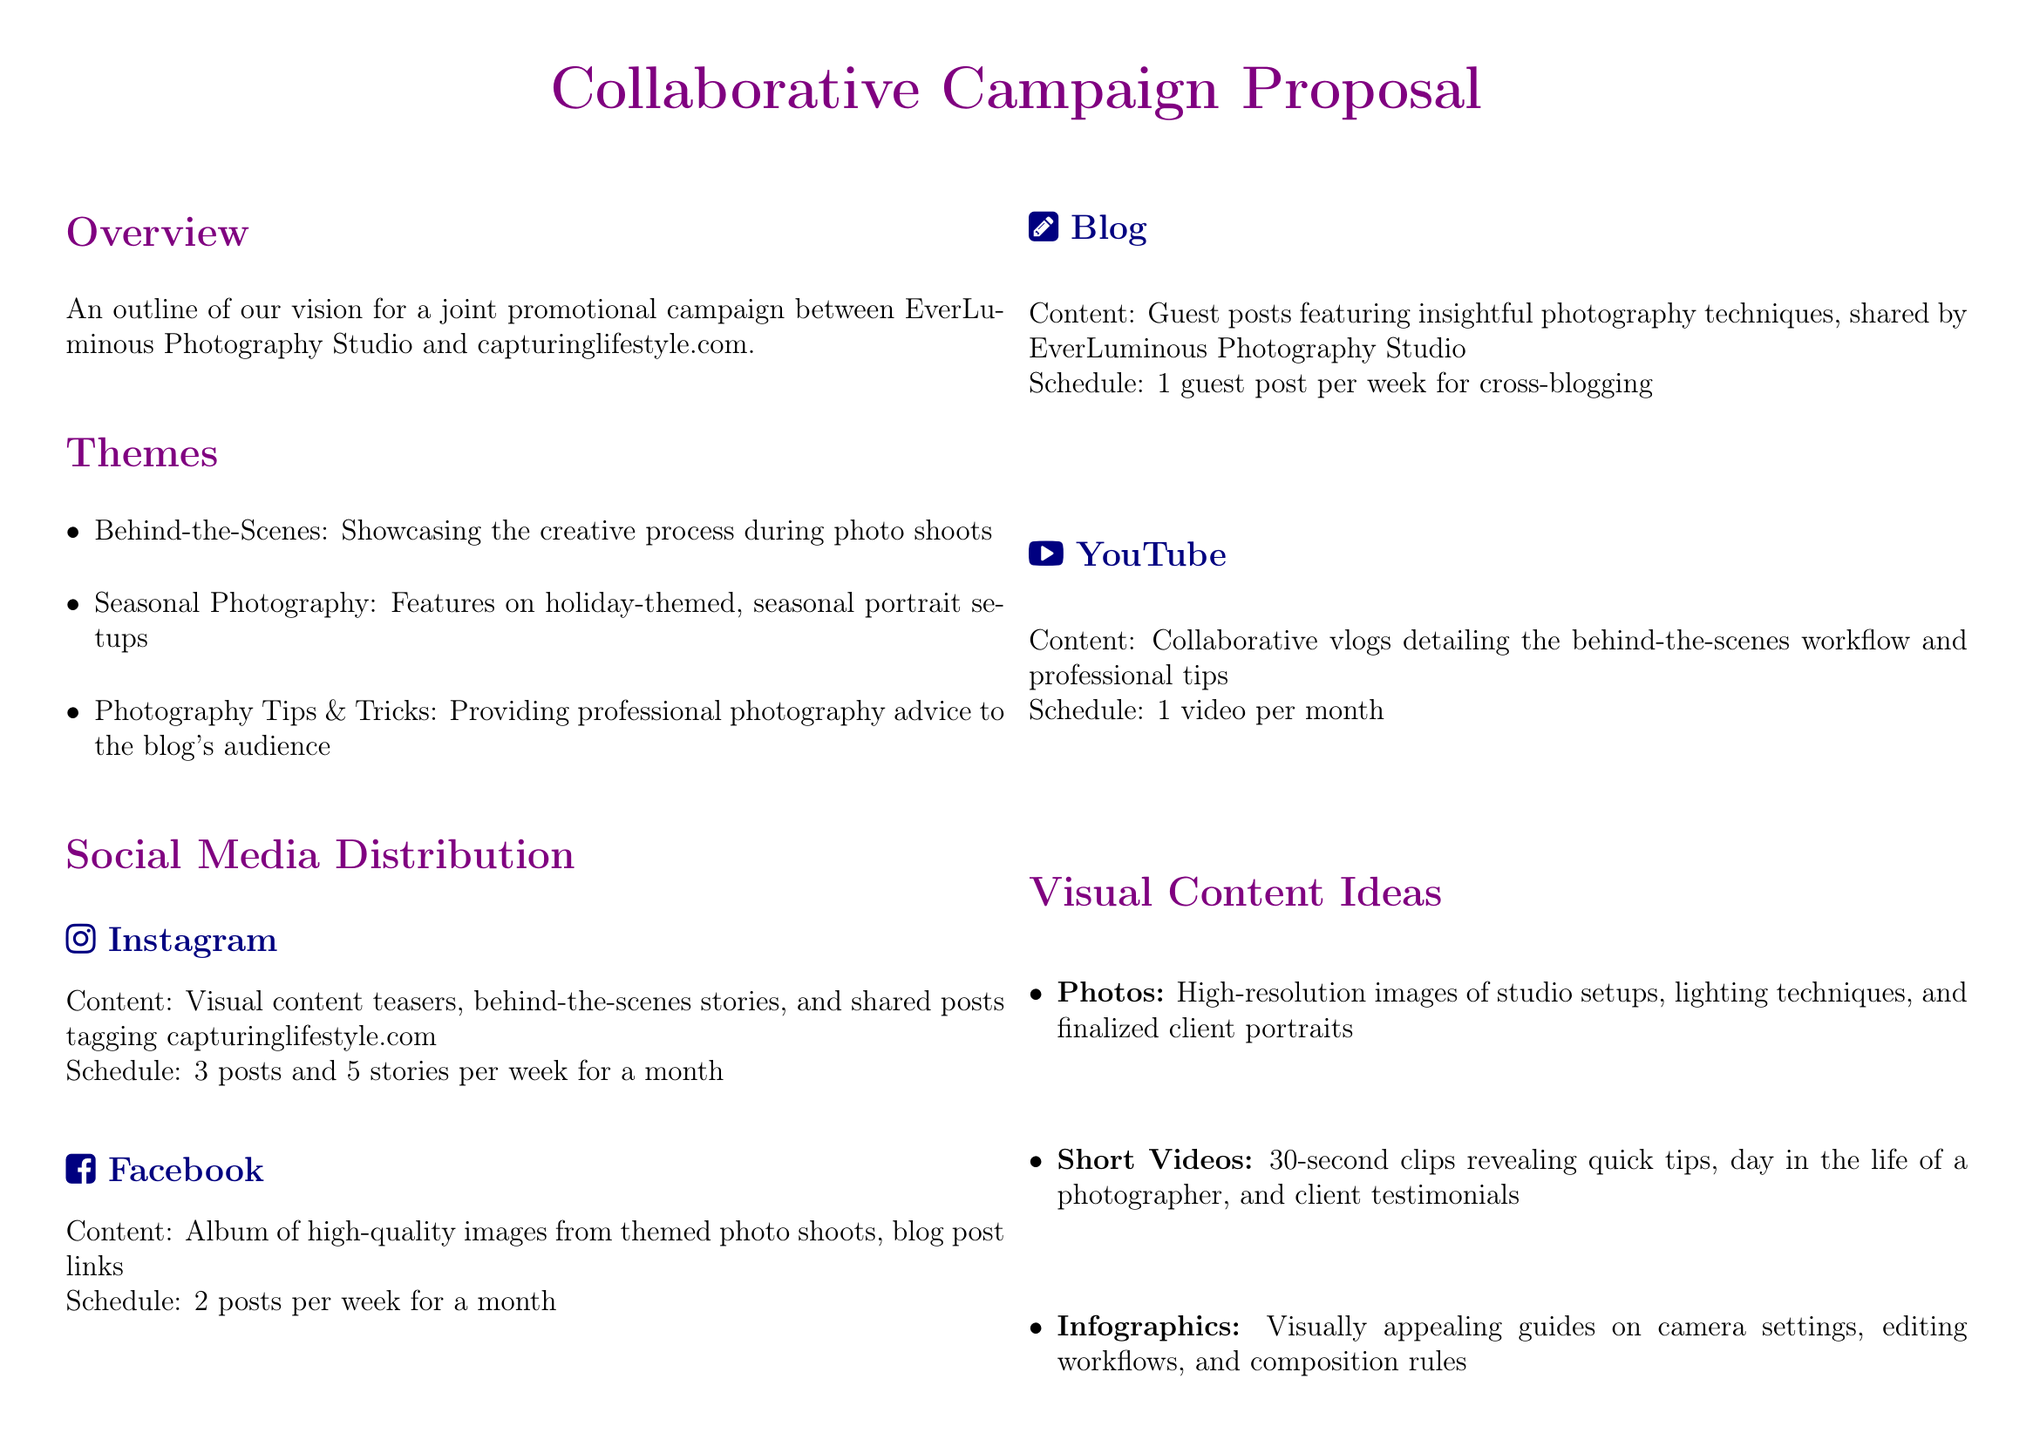what is the name of the photography studio? The document specifies the name of the photography studio as "EverLuminous Photography Studio."
Answer: EverLuminous Photography Studio what are the themes proposed for the campaign? The document lists the themes as "Behind-the-Scenes," "Seasonal Photography," and "Photography Tips & Tricks."
Answer: Behind-the-Scenes, Seasonal Photography, Photography Tips & Tricks how many social media posts are scheduled for Instagram? The document states that there will be 3 posts scheduled for Instagram each week for a month, which totals to 12 posts.
Answer: 12 what is the content shared on Facebook? The document indicates that the content on Facebook includes an album of high-quality images from themed photo shoots and blog post links.
Answer: Album of high-quality images, blog post links how often will guest posts be featured on the blog? The document specifies that there will be 1 guest post per week for cross-blogging purposes.
Answer: 1 guest post per week what is the mutual benefit for the blogger? The document lists multiple benefits for the blogger, one being access to exclusive professional content.
Answer: Access to exclusive professional content what type of videos will be created for YouTube? The document states that the content for YouTube will be collaborative vlogs detailing behind-the-scenes workflow and professional tips.
Answer: Collaborative vlogs how many total posts are planned across all platforms? Summing the scheduled posts: 12 Instagram, 8 Facebook, 4 blog posts, and 1 YouTube video gives a total of 25 posts.
Answer: 25 